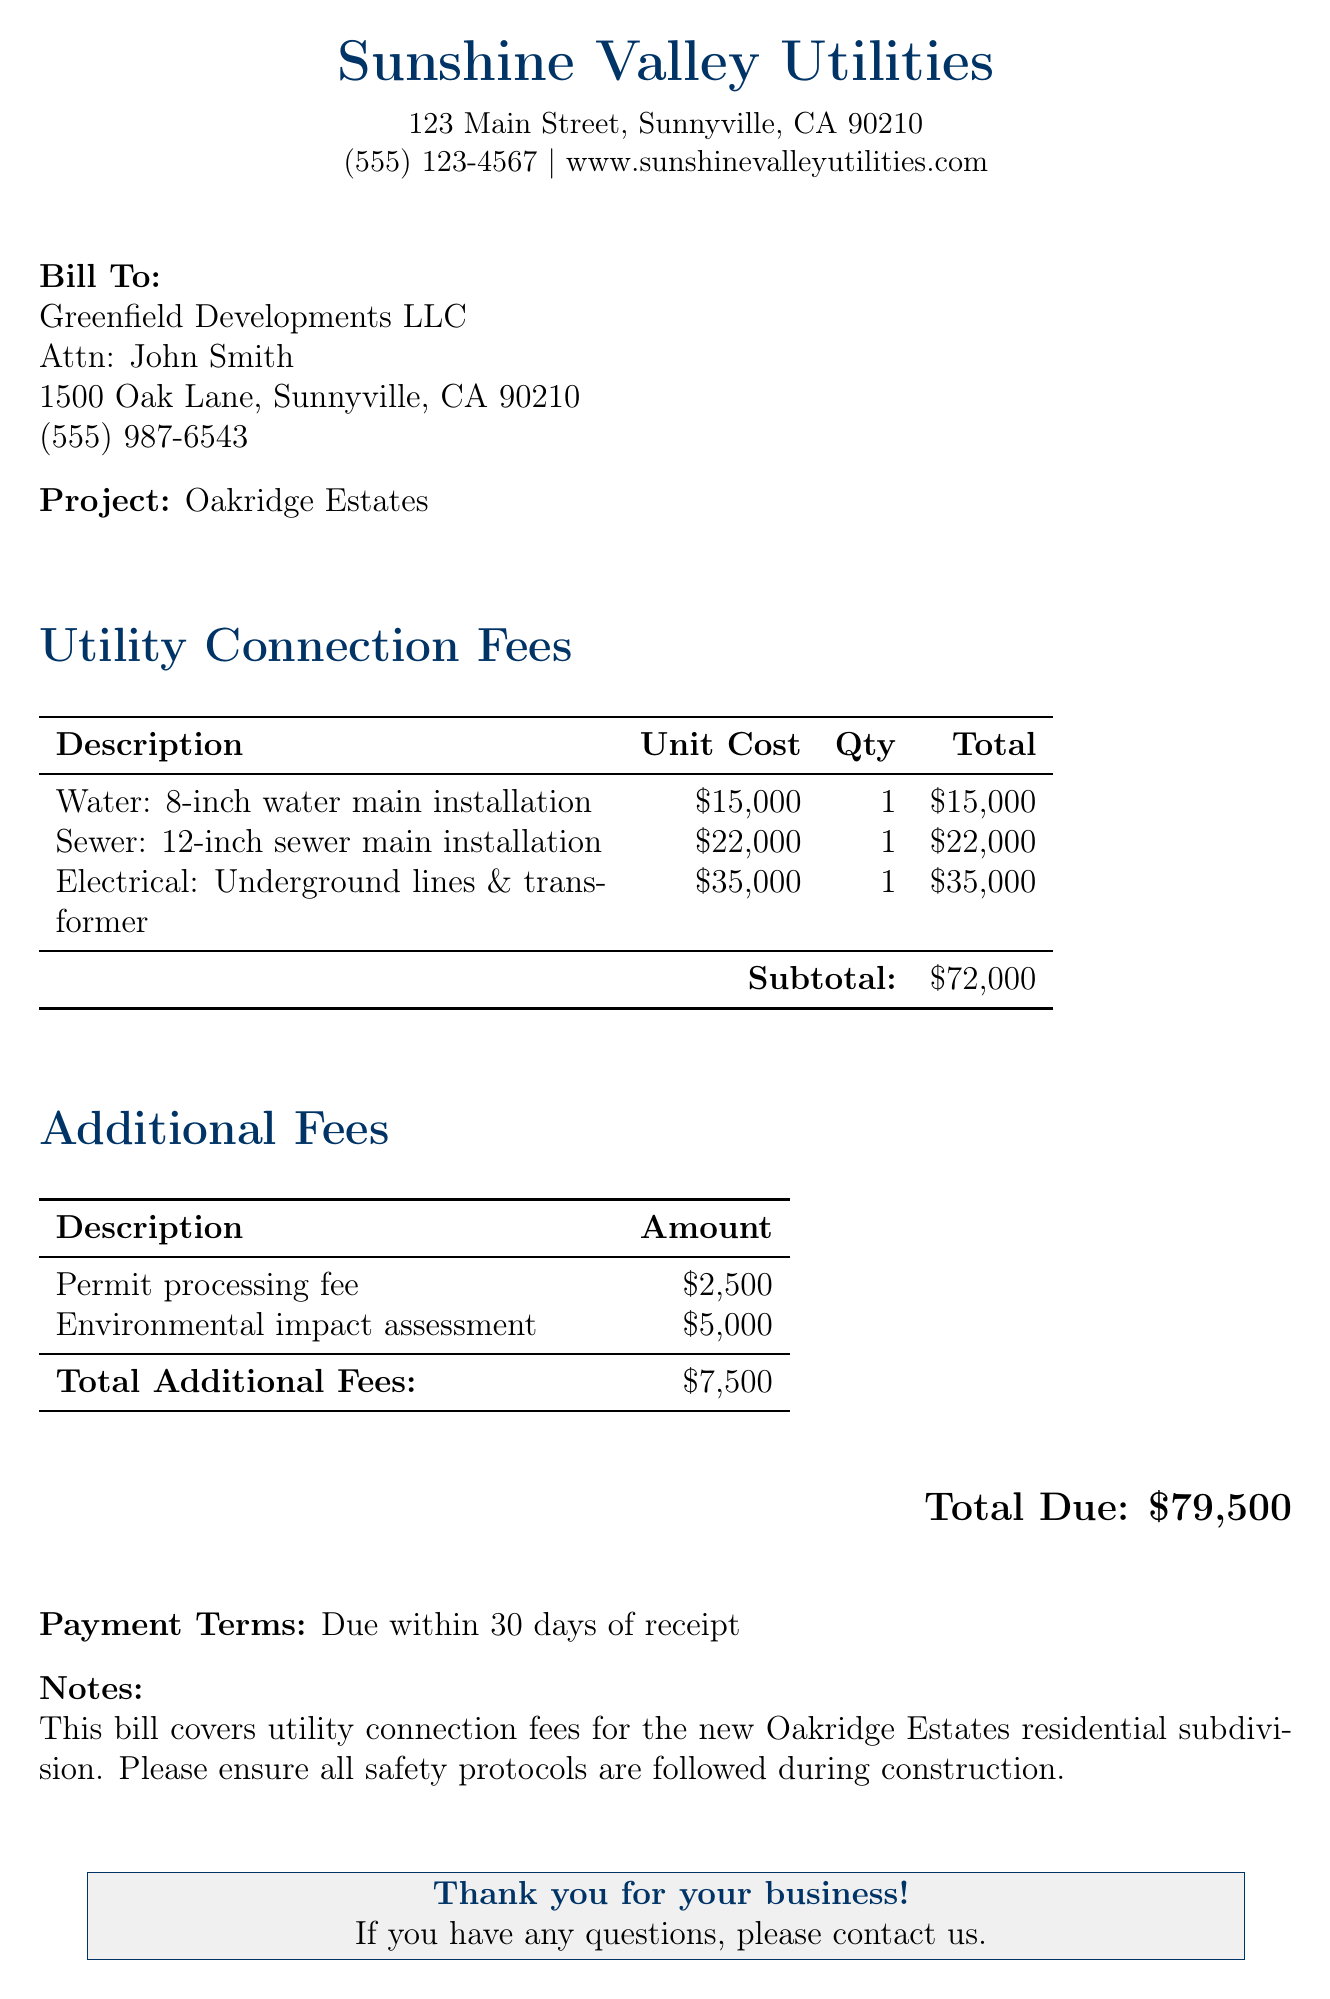What is the project name? The project name is stated in the 'Project' section of the document.
Answer: Oakridge Estates What is the total due amount? The total due is provided at the bottom of the document.
Answer: $79,500 What is the unit cost for the 12-inch sewer main installation? The unit cost is specified in the utility connection fees table.
Answer: $22,000 What is included in the additional fees? The 'Additional Fees' section lists any extra charges incurred.
Answer: Permit processing fee and Environmental impact assessment How much is the permit processing fee? This fee is detailed in the 'Additional Fees' section.
Answer: $2,500 How many types of utility connections are listed? The categories of utility connections are explicitly mentioned in the utility connection fees table.
Answer: 3 What is the subtotal for the utility connection fees? The subtotal is calculated and provided in the fees table.
Answer: $72,000 What is the environmental impact assessment fee? This fee is outlined under 'Additional Fees.'
Answer: $5,000 What is the payment term specified in the document? The payment terms are stated towards the end of the document.
Answer: Due within 30 days of receipt 